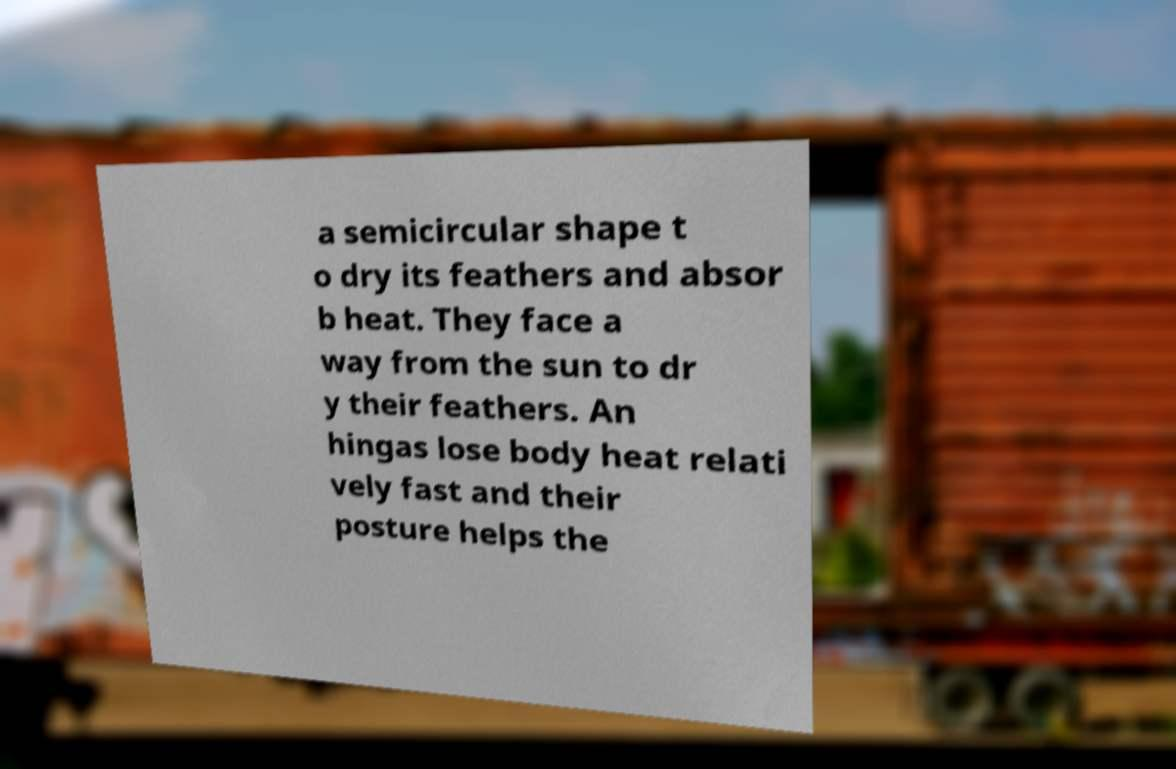What messages or text are displayed in this image? I need them in a readable, typed format. a semicircular shape t o dry its feathers and absor b heat. They face a way from the sun to dr y their feathers. An hingas lose body heat relati vely fast and their posture helps the 